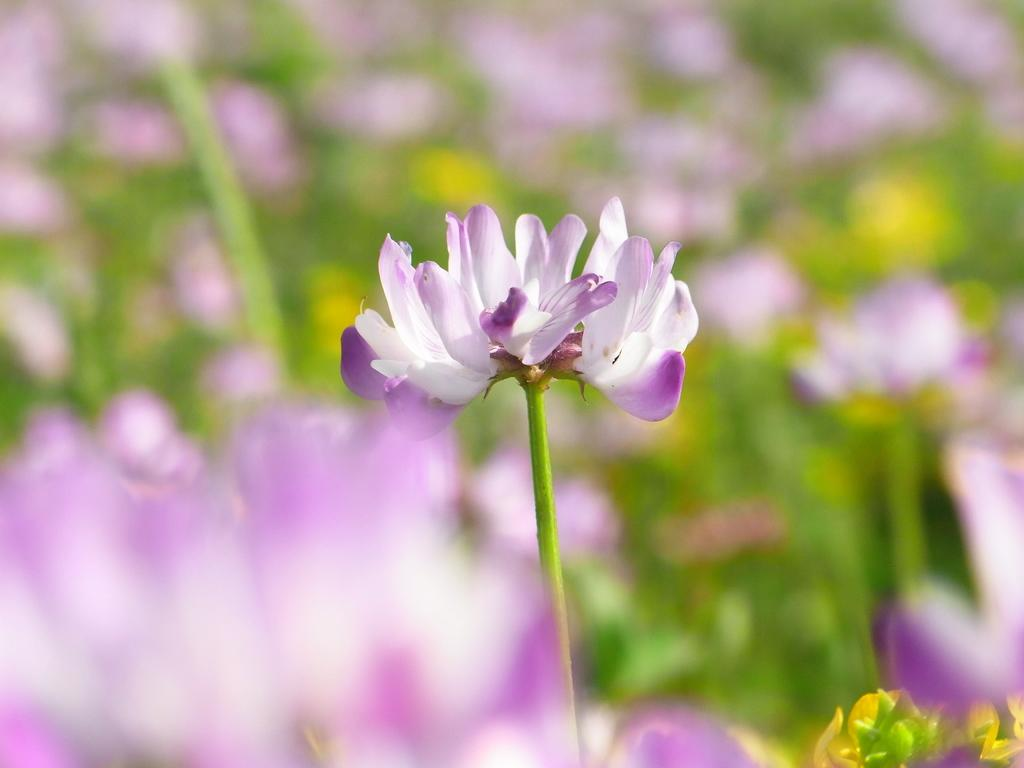What is the main subject in the foreground of the image? There is a flower in the foreground of the image. What can be seen at the bottom of the image? There are flowers at the bottom of the image, which are blurred. What is visible in the background of the image? There are flowers and greenery in the background of the image. Where is the basket of tomatoes located in the image? There is no basket of tomatoes present in the image. What type of harbor can be seen in the background of the image? There is no harbor visible in the image; it features flowers and greenery in the background. 